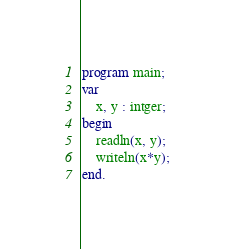Convert code to text. <code><loc_0><loc_0><loc_500><loc_500><_Pascal_>program main;
var
    x, y : intger;
begin
    readln(x, y);
    writeln(x*y);
end.
</code> 